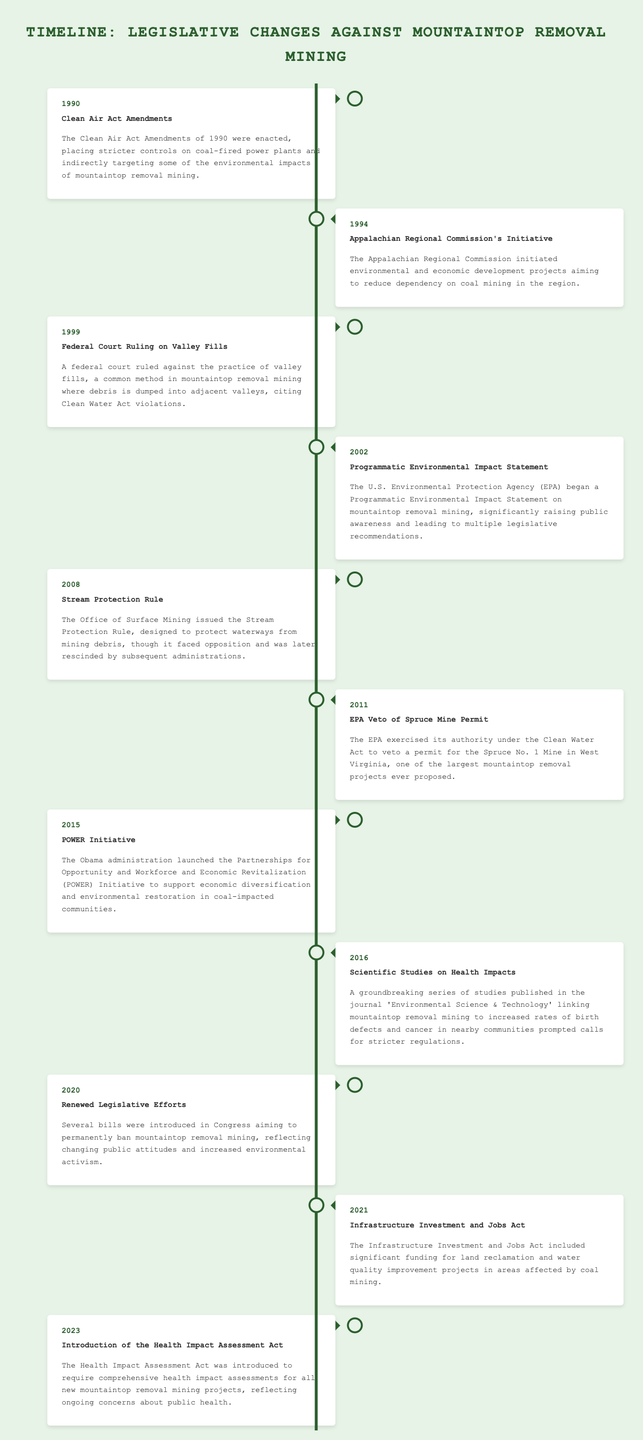What event was influenced by the Clean Air Act Amendments? The Clean Air Act Amendments of 1990 were enacted, placing stricter controls on coal-fired power plants, indirectly targeting environmental impacts of mountaintop removal mining.
Answer: Clean Air Act Amendments What year did the EPA veto the Spruce Mine Permit? The EPA exercised its authority to veto the permit for the Spruce No. 1 Mine in 2011, a significant action against mountaintop removal mining.
Answer: 2011 What initiative did the Appalachian Regional Commission launch? The Appalachian Regional Commission initiated environmental and economic development projects aiming to reduce dependency on coal mining in 1994.
Answer: Initiative How many events are recorded in the timeline? The timeline includes several key events from 1990 to 2023, each related to legislative changes against mountaintop removal mining.
Answer: 10 What significant rule was issued in 2008? The Office of Surface Mining issued the Stream Protection Rule in 2008, aimed at protecting waterways from mining debris.
Answer: Stream Protection Rule Which year marked the introduction of new legislative efforts to ban mountaintop removal mining? The year 2020 saw the introduction of several bills aiming to permanently ban mountaintop removal mining, reflecting changing public attitudes.
Answer: 2020 What act was introduced in 2023? The Health Impact Assessment Act was introduced in 2023 to require health assessments for new mountaintop removal mining projects.
Answer: Health Impact Assessment Act Which administration launched the POWER Initiative? The Obama administration launched the Partnerships for Opportunity and Workforce and Economic Revitalization (POWER) Initiative in 2015.
Answer: Obama administration What was the focus of studies published in 2016? The studies published in 2016 linked mountaintop removal mining to increased health issues, prompting calls for stricter regulations.
Answer: Health impacts 